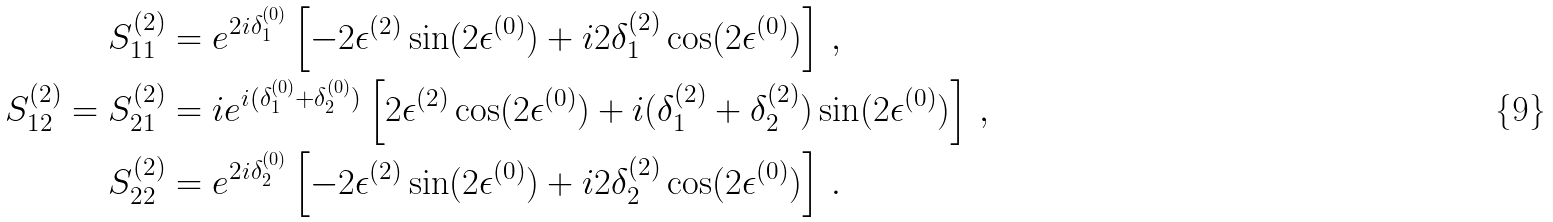Convert formula to latex. <formula><loc_0><loc_0><loc_500><loc_500>S ^ { ( 2 ) } _ { 1 1 } & = e ^ { 2 i \delta _ { 1 } ^ { ( 0 ) } } \left [ - 2 \epsilon ^ { ( 2 ) } \sin ( 2 \epsilon ^ { ( 0 ) } ) + i 2 \delta _ { 1 } ^ { ( 2 ) } \cos ( 2 \epsilon ^ { ( 0 ) } ) \right ] \, , \\ S ^ { ( 2 ) } _ { 1 2 } = S ^ { ( 2 ) } _ { 2 1 } & = i e ^ { i ( \delta _ { 1 } ^ { ( 0 ) } + \delta _ { 2 } ^ { ( 0 ) } ) } \left [ 2 \epsilon ^ { ( 2 ) } \cos ( 2 \epsilon ^ { ( 0 ) } ) + i ( \delta _ { 1 } ^ { ( 2 ) } + \delta _ { 2 } ^ { ( 2 ) } ) \sin ( 2 \epsilon ^ { ( 0 ) } ) \right ] \, , \\ S ^ { ( 2 ) } _ { 2 2 } & = e ^ { 2 i \delta _ { 2 } ^ { ( 0 ) } } \left [ - 2 \epsilon ^ { ( 2 ) } \sin ( 2 \epsilon ^ { ( 0 ) } ) + i 2 \delta _ { 2 } ^ { ( 2 ) } \cos ( 2 \epsilon ^ { ( 0 ) } ) \right ] \, .</formula> 